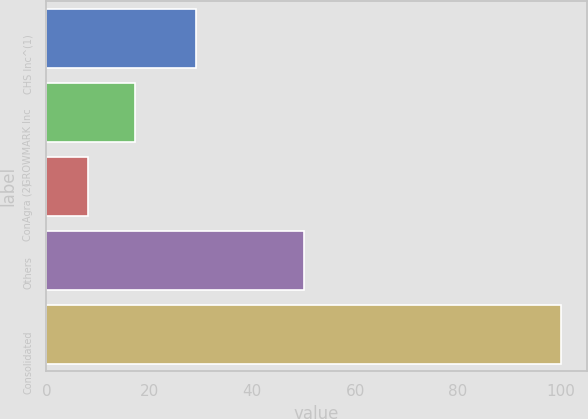Convert chart to OTSL. <chart><loc_0><loc_0><loc_500><loc_500><bar_chart><fcel>CHS Inc^(1)<fcel>GROWMARK Inc<fcel>ConAgra (2)<fcel>Others<fcel>Consolidated<nl><fcel>29<fcel>17.2<fcel>8<fcel>50<fcel>100<nl></chart> 